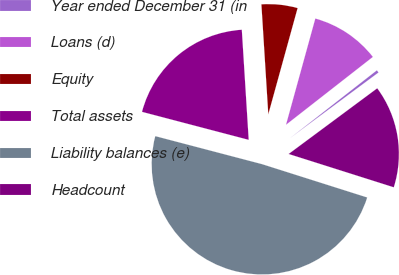<chart> <loc_0><loc_0><loc_500><loc_500><pie_chart><fcel>Year ended December 31 (in<fcel>Loans (d)<fcel>Equity<fcel>Total assets<fcel>Liability balances (e)<fcel>Headcount<nl><fcel>0.4%<fcel>10.16%<fcel>5.28%<fcel>19.92%<fcel>49.2%<fcel>15.04%<nl></chart> 